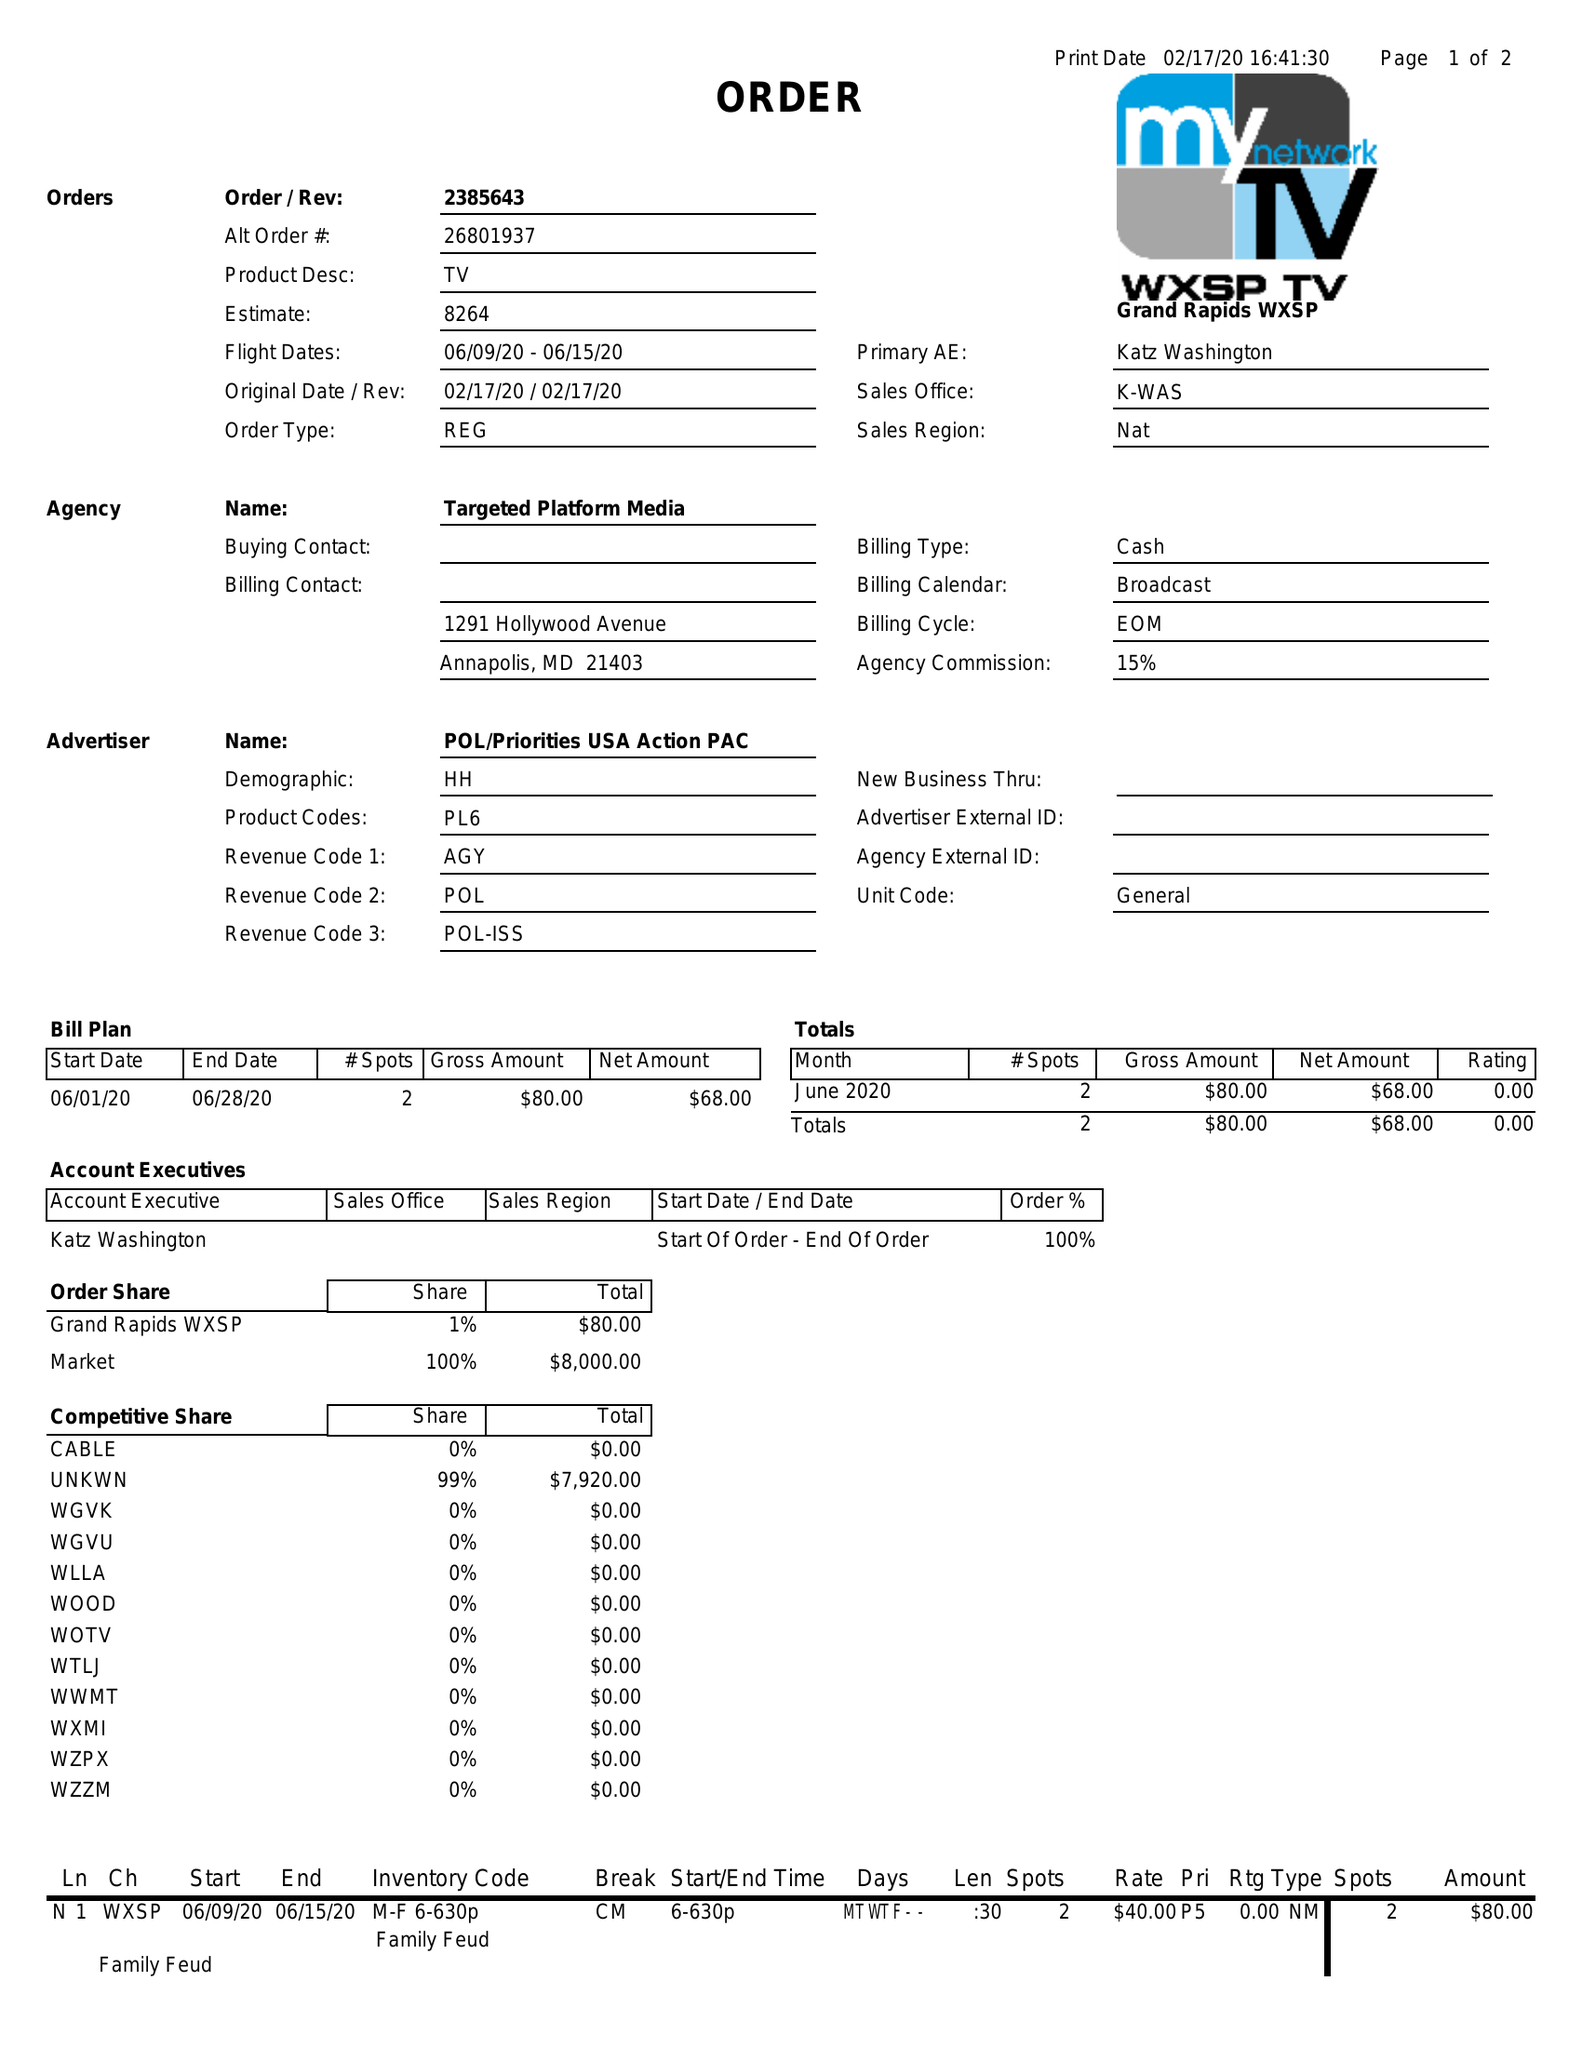What is the value for the flight_from?
Answer the question using a single word or phrase. 06/09/20 